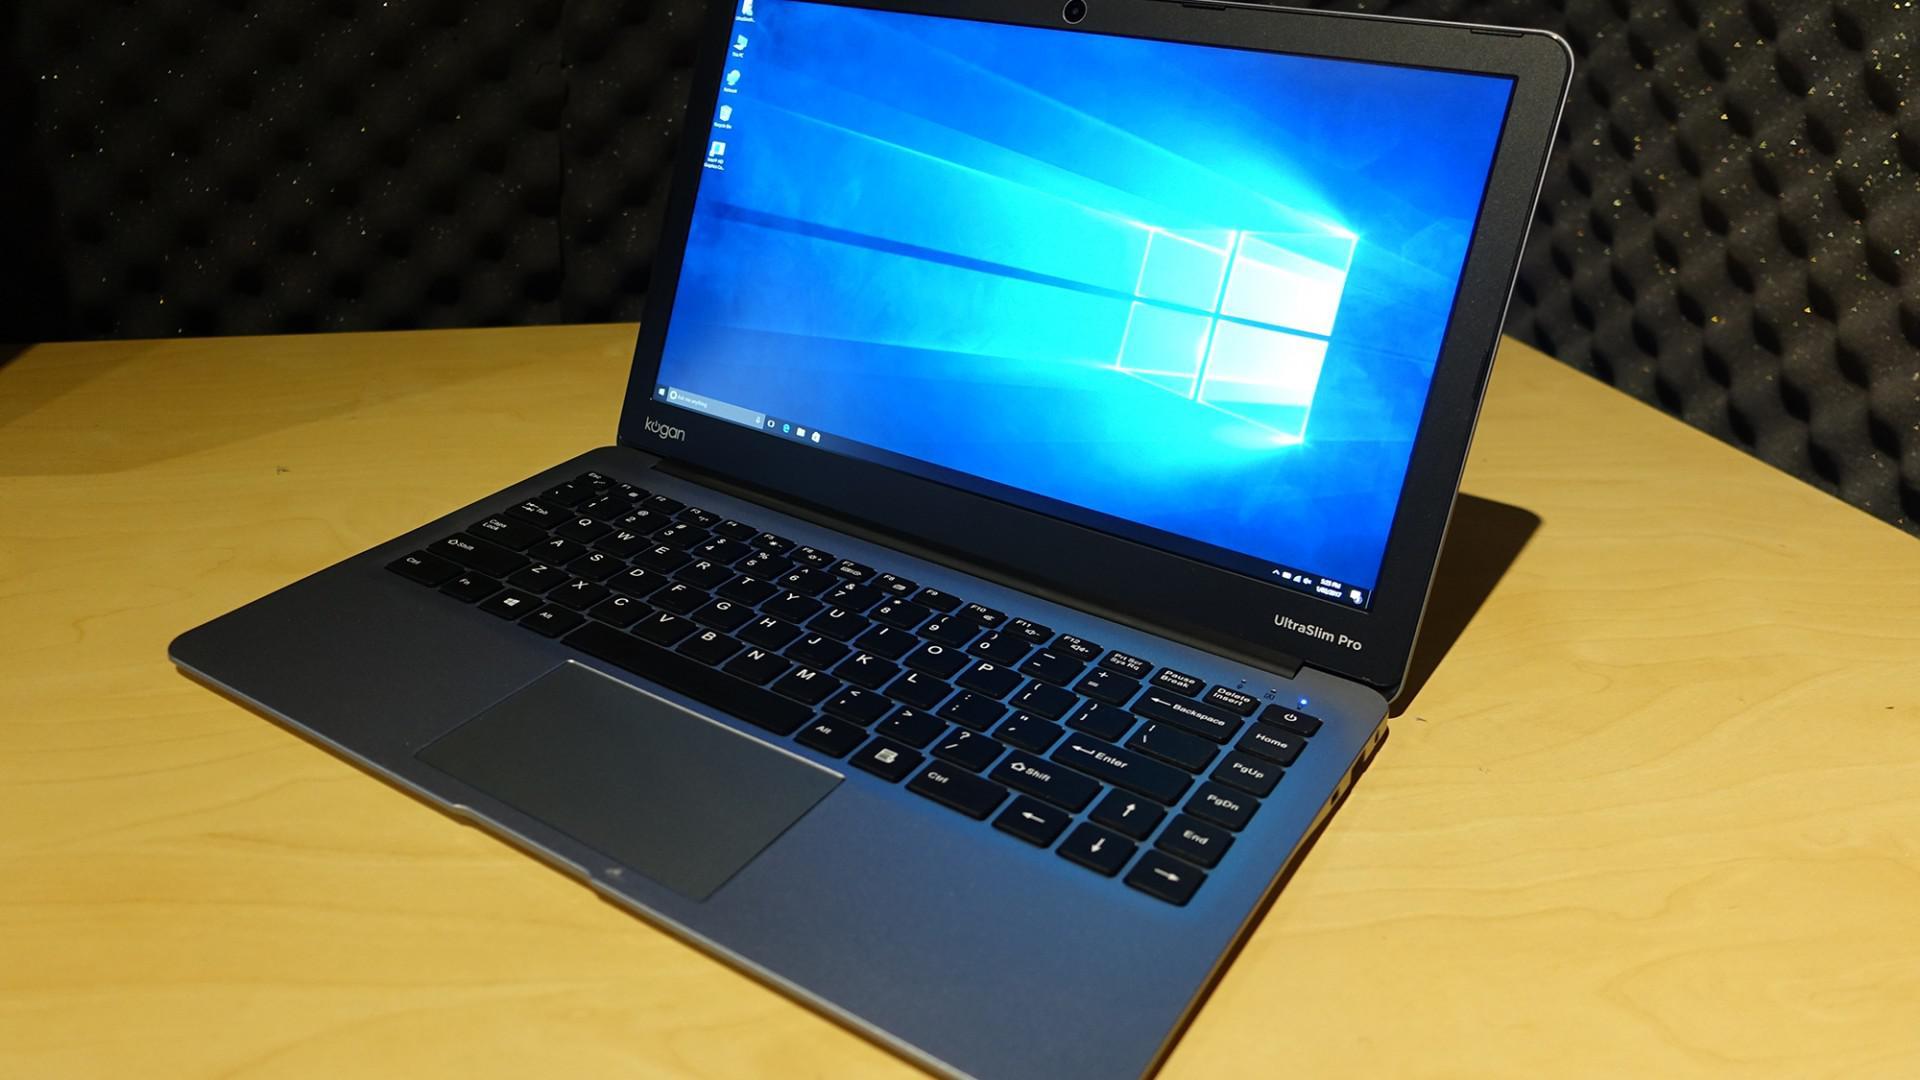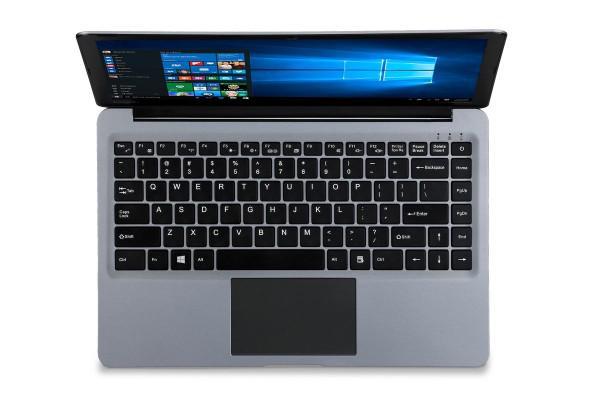The first image is the image on the left, the second image is the image on the right. Evaluate the accuracy of this statement regarding the images: "One image shows an open laptop angled facing leftward, and the other image includes a head-on aerial view of an open laptop.". Is it true? Answer yes or no. Yes. The first image is the image on the left, the second image is the image on the right. For the images displayed, is the sentence "There are two screens in one of the images." factually correct? Answer yes or no. No. 